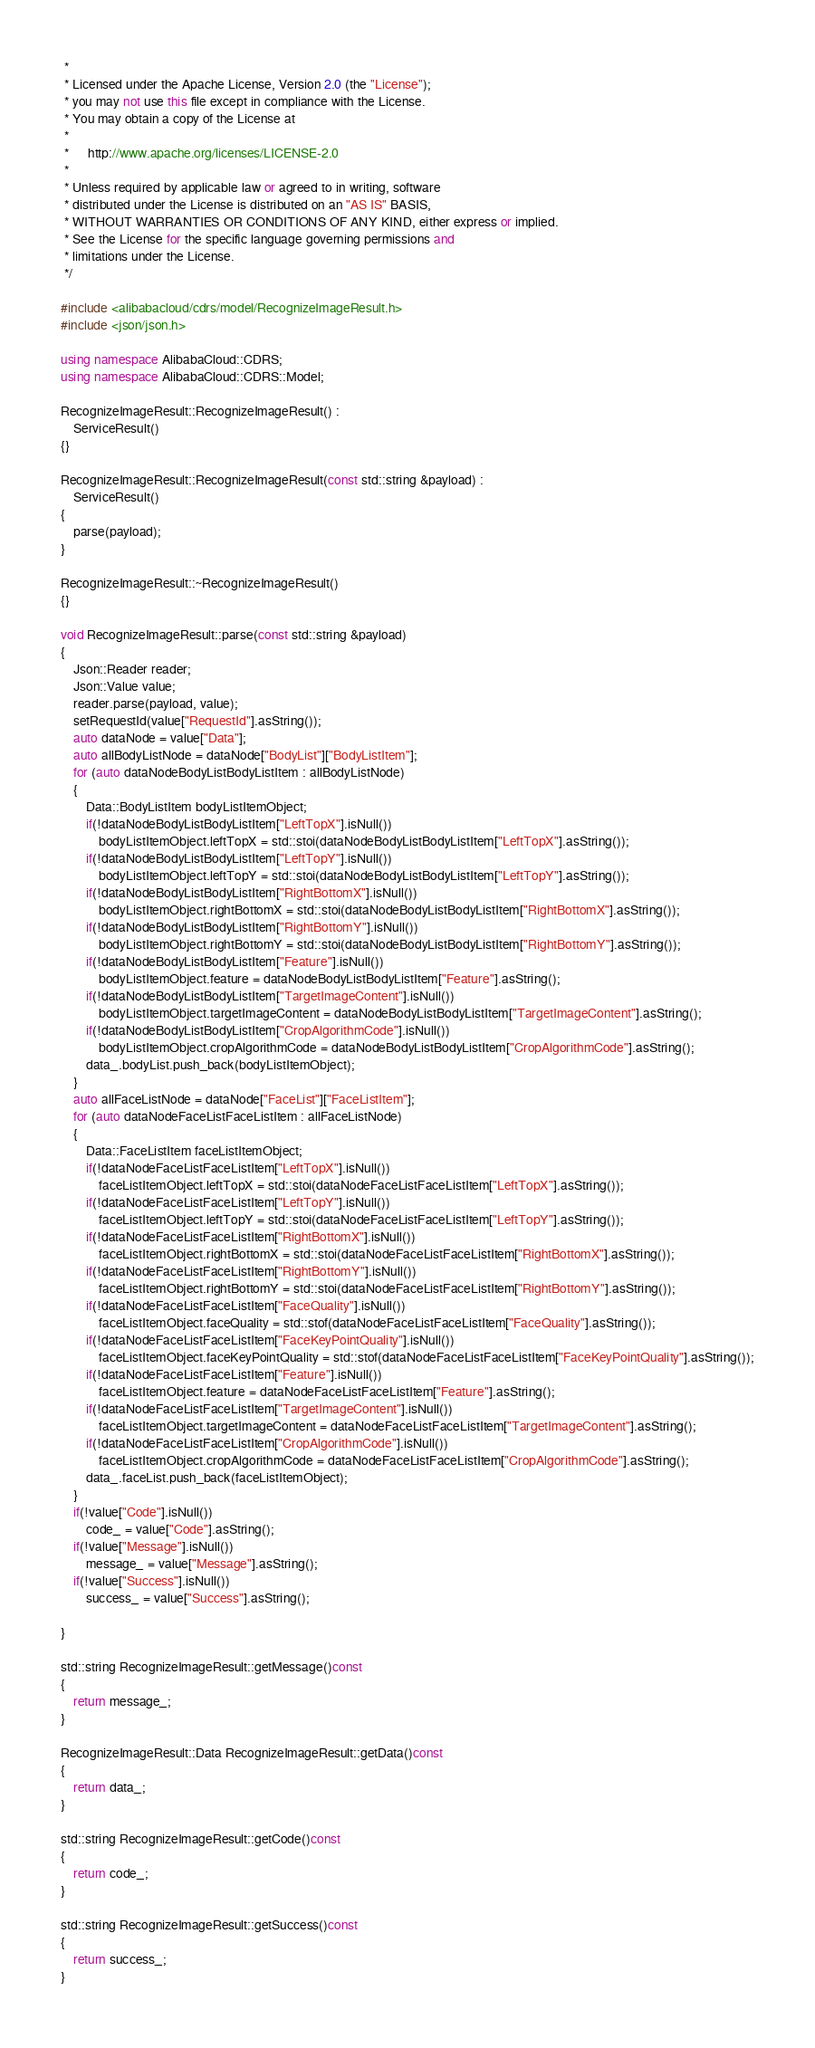Convert code to text. <code><loc_0><loc_0><loc_500><loc_500><_C++_> * 
 * Licensed under the Apache License, Version 2.0 (the "License");
 * you may not use this file except in compliance with the License.
 * You may obtain a copy of the License at
 * 
 *      http://www.apache.org/licenses/LICENSE-2.0
 * 
 * Unless required by applicable law or agreed to in writing, software
 * distributed under the License is distributed on an "AS IS" BASIS,
 * WITHOUT WARRANTIES OR CONDITIONS OF ANY KIND, either express or implied.
 * See the License for the specific language governing permissions and
 * limitations under the License.
 */

#include <alibabacloud/cdrs/model/RecognizeImageResult.h>
#include <json/json.h>

using namespace AlibabaCloud::CDRS;
using namespace AlibabaCloud::CDRS::Model;

RecognizeImageResult::RecognizeImageResult() :
	ServiceResult()
{}

RecognizeImageResult::RecognizeImageResult(const std::string &payload) :
	ServiceResult()
{
	parse(payload);
}

RecognizeImageResult::~RecognizeImageResult()
{}

void RecognizeImageResult::parse(const std::string &payload)
{
	Json::Reader reader;
	Json::Value value;
	reader.parse(payload, value);
	setRequestId(value["RequestId"].asString());
	auto dataNode = value["Data"];
	auto allBodyListNode = dataNode["BodyList"]["BodyListItem"];
	for (auto dataNodeBodyListBodyListItem : allBodyListNode)
	{
		Data::BodyListItem bodyListItemObject;
		if(!dataNodeBodyListBodyListItem["LeftTopX"].isNull())
			bodyListItemObject.leftTopX = std::stoi(dataNodeBodyListBodyListItem["LeftTopX"].asString());
		if(!dataNodeBodyListBodyListItem["LeftTopY"].isNull())
			bodyListItemObject.leftTopY = std::stoi(dataNodeBodyListBodyListItem["LeftTopY"].asString());
		if(!dataNodeBodyListBodyListItem["RightBottomX"].isNull())
			bodyListItemObject.rightBottomX = std::stoi(dataNodeBodyListBodyListItem["RightBottomX"].asString());
		if(!dataNodeBodyListBodyListItem["RightBottomY"].isNull())
			bodyListItemObject.rightBottomY = std::stoi(dataNodeBodyListBodyListItem["RightBottomY"].asString());
		if(!dataNodeBodyListBodyListItem["Feature"].isNull())
			bodyListItemObject.feature = dataNodeBodyListBodyListItem["Feature"].asString();
		if(!dataNodeBodyListBodyListItem["TargetImageContent"].isNull())
			bodyListItemObject.targetImageContent = dataNodeBodyListBodyListItem["TargetImageContent"].asString();
		if(!dataNodeBodyListBodyListItem["CropAlgorithmCode"].isNull())
			bodyListItemObject.cropAlgorithmCode = dataNodeBodyListBodyListItem["CropAlgorithmCode"].asString();
		data_.bodyList.push_back(bodyListItemObject);
	}
	auto allFaceListNode = dataNode["FaceList"]["FaceListItem"];
	for (auto dataNodeFaceListFaceListItem : allFaceListNode)
	{
		Data::FaceListItem faceListItemObject;
		if(!dataNodeFaceListFaceListItem["LeftTopX"].isNull())
			faceListItemObject.leftTopX = std::stoi(dataNodeFaceListFaceListItem["LeftTopX"].asString());
		if(!dataNodeFaceListFaceListItem["LeftTopY"].isNull())
			faceListItemObject.leftTopY = std::stoi(dataNodeFaceListFaceListItem["LeftTopY"].asString());
		if(!dataNodeFaceListFaceListItem["RightBottomX"].isNull())
			faceListItemObject.rightBottomX = std::stoi(dataNodeFaceListFaceListItem["RightBottomX"].asString());
		if(!dataNodeFaceListFaceListItem["RightBottomY"].isNull())
			faceListItemObject.rightBottomY = std::stoi(dataNodeFaceListFaceListItem["RightBottomY"].asString());
		if(!dataNodeFaceListFaceListItem["FaceQuality"].isNull())
			faceListItemObject.faceQuality = std::stof(dataNodeFaceListFaceListItem["FaceQuality"].asString());
		if(!dataNodeFaceListFaceListItem["FaceKeyPointQuality"].isNull())
			faceListItemObject.faceKeyPointQuality = std::stof(dataNodeFaceListFaceListItem["FaceKeyPointQuality"].asString());
		if(!dataNodeFaceListFaceListItem["Feature"].isNull())
			faceListItemObject.feature = dataNodeFaceListFaceListItem["Feature"].asString();
		if(!dataNodeFaceListFaceListItem["TargetImageContent"].isNull())
			faceListItemObject.targetImageContent = dataNodeFaceListFaceListItem["TargetImageContent"].asString();
		if(!dataNodeFaceListFaceListItem["CropAlgorithmCode"].isNull())
			faceListItemObject.cropAlgorithmCode = dataNodeFaceListFaceListItem["CropAlgorithmCode"].asString();
		data_.faceList.push_back(faceListItemObject);
	}
	if(!value["Code"].isNull())
		code_ = value["Code"].asString();
	if(!value["Message"].isNull())
		message_ = value["Message"].asString();
	if(!value["Success"].isNull())
		success_ = value["Success"].asString();

}

std::string RecognizeImageResult::getMessage()const
{
	return message_;
}

RecognizeImageResult::Data RecognizeImageResult::getData()const
{
	return data_;
}

std::string RecognizeImageResult::getCode()const
{
	return code_;
}

std::string RecognizeImageResult::getSuccess()const
{
	return success_;
}

</code> 